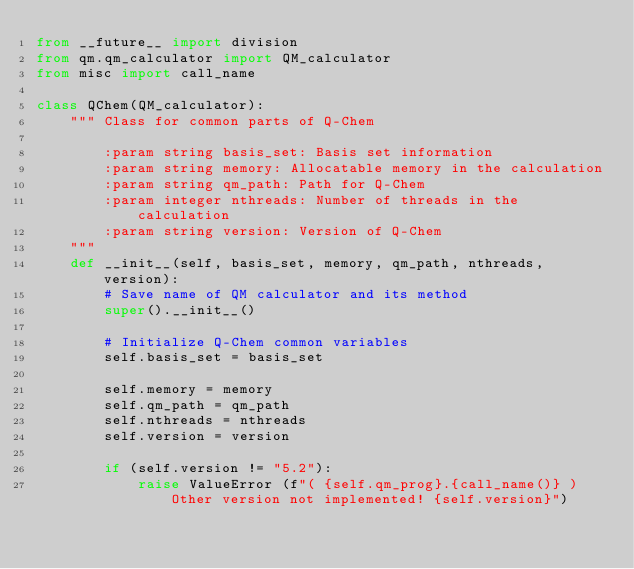Convert code to text. <code><loc_0><loc_0><loc_500><loc_500><_Python_>from __future__ import division
from qm.qm_calculator import QM_calculator
from misc import call_name

class QChem(QM_calculator):
    """ Class for common parts of Q-Chem

        :param string basis_set: Basis set information
        :param string memory: Allocatable memory in the calculation
        :param string qm_path: Path for Q-Chem
        :param integer nthreads: Number of threads in the calculation
        :param string version: Version of Q-Chem
    """
    def __init__(self, basis_set, memory, qm_path, nthreads, version):
        # Save name of QM calculator and its method
        super().__init__()

        # Initialize Q-Chem common variables
        self.basis_set = basis_set

        self.memory = memory
        self.qm_path = qm_path
        self.nthreads = nthreads
        self.version = version

        if (self.version != "5.2"):
            raise ValueError (f"( {self.qm_prog}.{call_name()} ) Other version not implemented! {self.version}")
</code> 